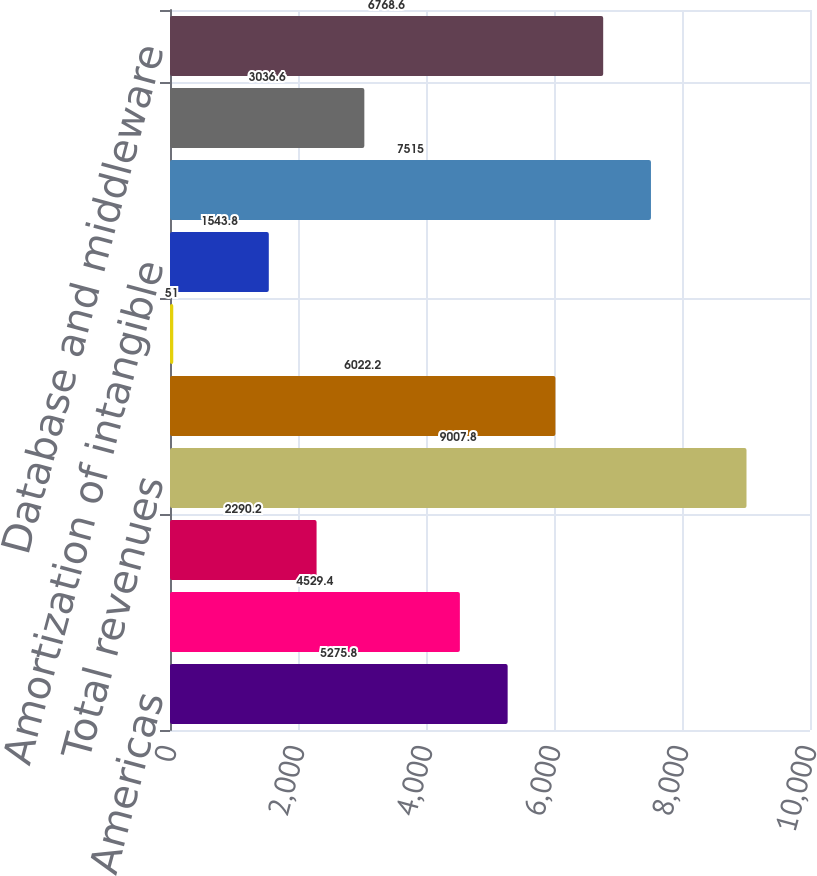<chart> <loc_0><loc_0><loc_500><loc_500><bar_chart><fcel>Americas<fcel>EMEA<fcel>Asia Pacific<fcel>Total revenues<fcel>Sales and marketing (1)<fcel>Stock-based compensation<fcel>Amortization of intangible<fcel>Total expenses<fcel>Total Margin<fcel>Database and middleware<nl><fcel>5275.8<fcel>4529.4<fcel>2290.2<fcel>9007.8<fcel>6022.2<fcel>51<fcel>1543.8<fcel>7515<fcel>3036.6<fcel>6768.6<nl></chart> 